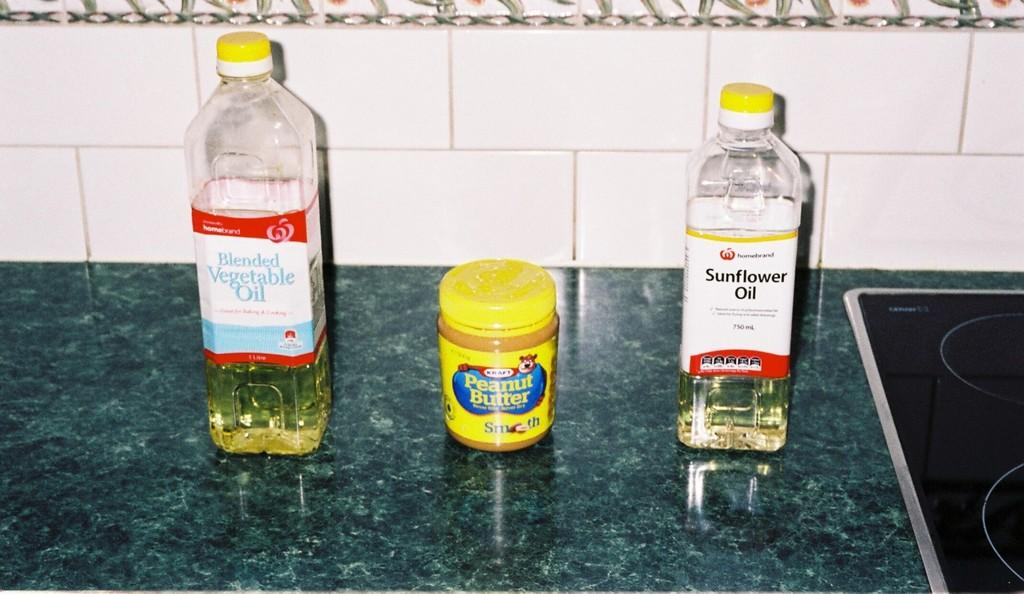Provide a one-sentence caption for the provided image. A peanut butter jar stands between two bottles of oil. 